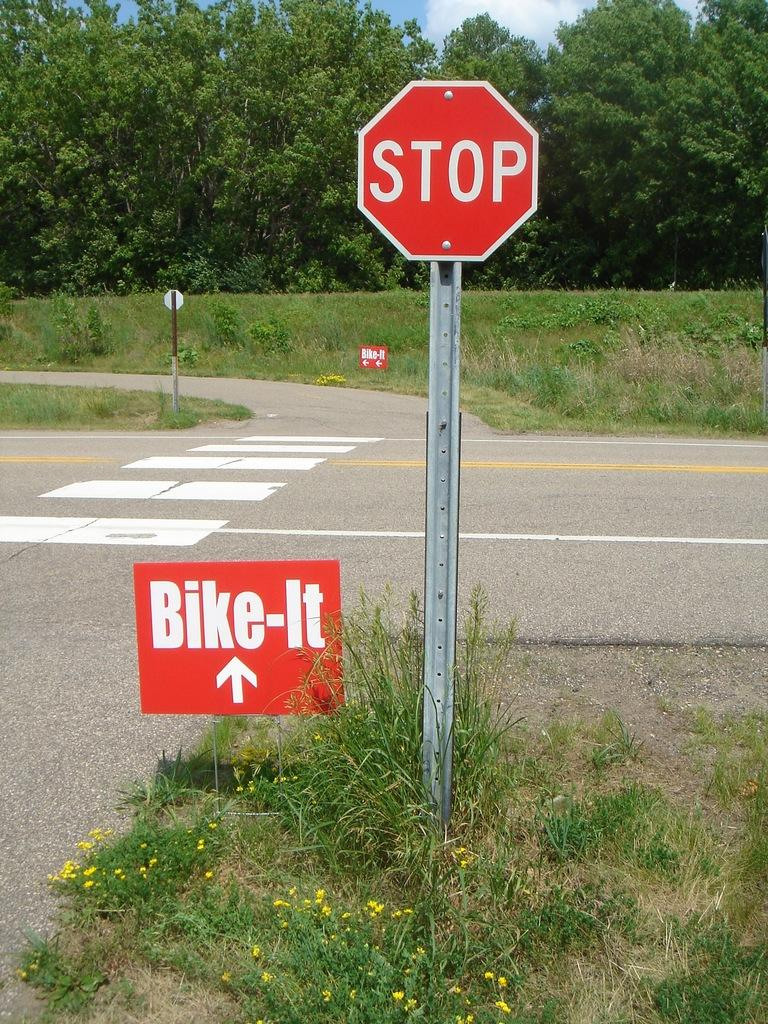<image>
Offer a succinct explanation of the picture presented. A red stop sign and on the bottom ground a red Bike it sign. 